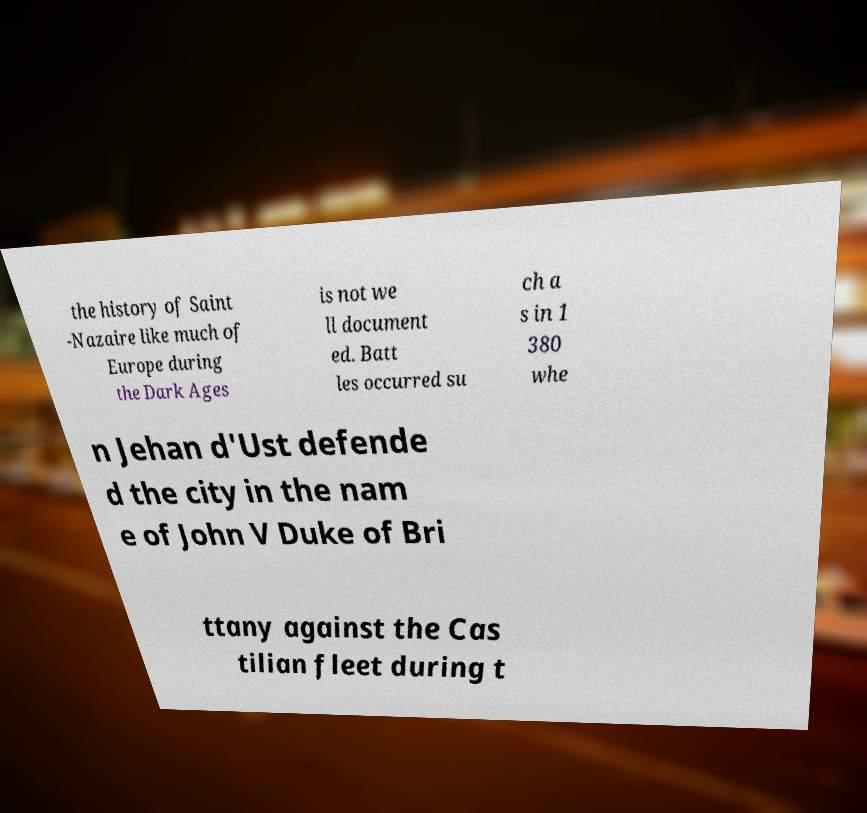Please identify and transcribe the text found in this image. the history of Saint -Nazaire like much of Europe during the Dark Ages is not we ll document ed. Batt les occurred su ch a s in 1 380 whe n Jehan d'Ust defende d the city in the nam e of John V Duke of Bri ttany against the Cas tilian fleet during t 